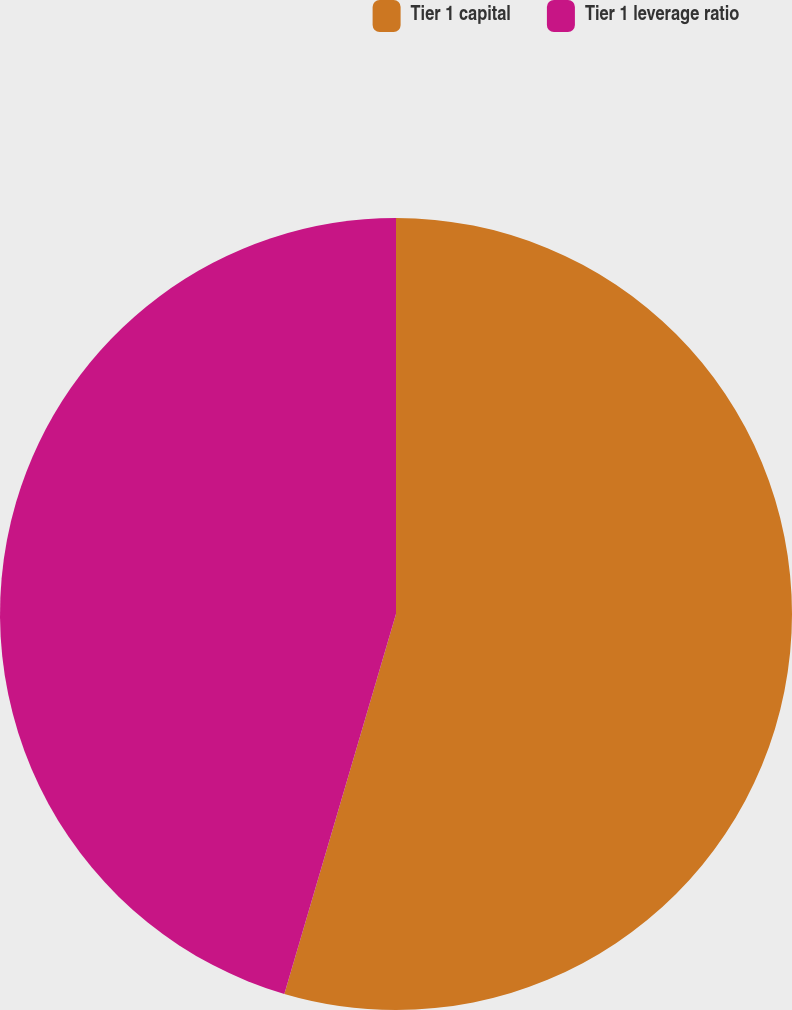<chart> <loc_0><loc_0><loc_500><loc_500><pie_chart><fcel>Tier 1 capital<fcel>Tier 1 leverage ratio<nl><fcel>54.55%<fcel>45.45%<nl></chart> 